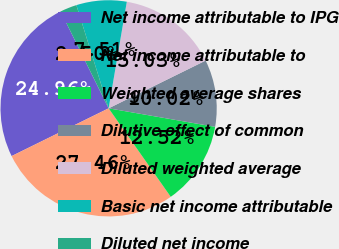<chart> <loc_0><loc_0><loc_500><loc_500><pie_chart><fcel>Net income attributable to IPG<fcel>Net income attributable to<fcel>Weighted average shares<fcel>Dilutive effect of common<fcel>Diluted weighted average<fcel>Basic net income attributable<fcel>Diluted net income<nl><fcel>24.96%<fcel>27.46%<fcel>12.52%<fcel>10.02%<fcel>15.03%<fcel>7.51%<fcel>2.5%<nl></chart> 